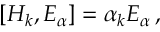Convert formula to latex. <formula><loc_0><loc_0><loc_500><loc_500>\left [ H _ { k } , E _ { \alpha } \right ] = \alpha _ { k } E _ { \alpha } \, ,</formula> 